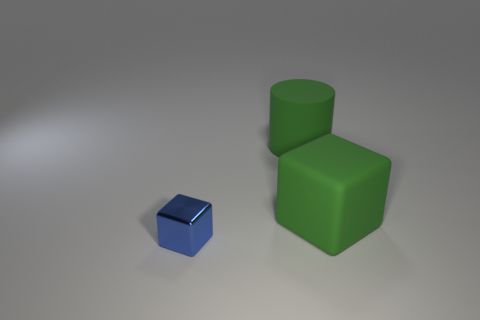What material is the thing that is the same color as the large cylinder?
Make the answer very short. Rubber. What number of gray shiny spheres are there?
Ensure brevity in your answer.  0. Is the number of big cubes less than the number of large gray things?
Give a very brief answer. No. What is the material of the green thing that is the same size as the rubber cylinder?
Your response must be concise. Rubber. How many objects are either small gray spheres or blue shiny objects?
Your answer should be compact. 1. What number of things are both behind the blue shiny block and left of the rubber cube?
Ensure brevity in your answer.  1. Is the number of tiny objects that are behind the matte cylinder less than the number of big cylinders?
Make the answer very short. Yes. The green matte object that is the same size as the green matte block is what shape?
Give a very brief answer. Cylinder. How many other objects are there of the same color as the metallic cube?
Your answer should be compact. 0. Do the blue object and the rubber cylinder have the same size?
Provide a short and direct response. No. 